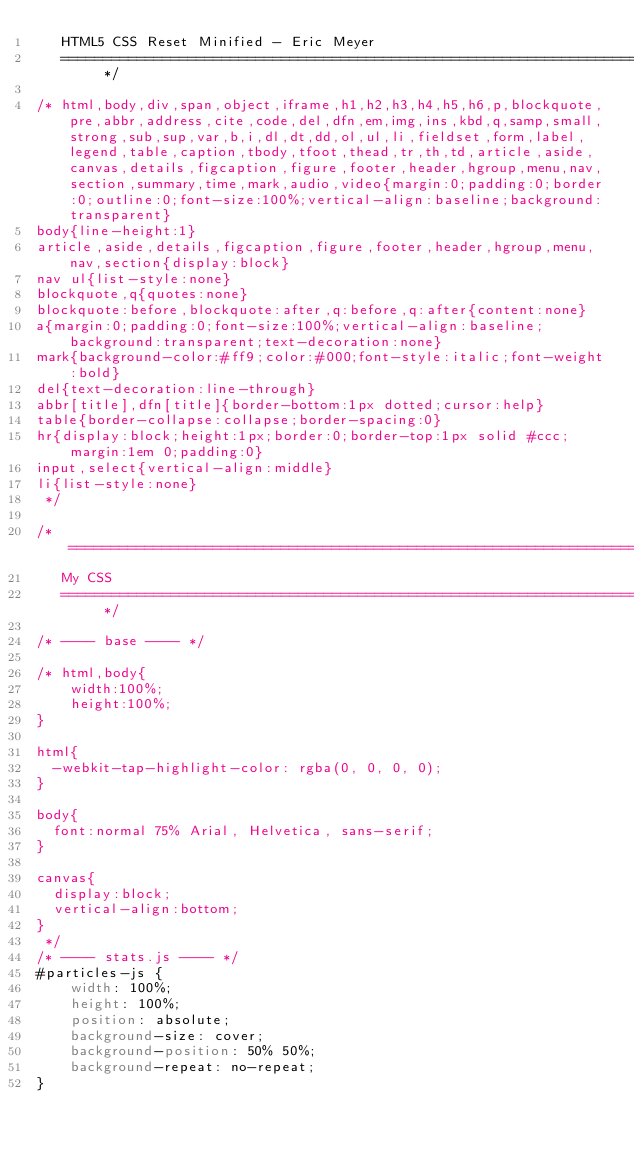<code> <loc_0><loc_0><loc_500><loc_500><_CSS_>   HTML5 CSS Reset Minified - Eric Meyer
   ========================================================================== */

/* html,body,div,span,object,iframe,h1,h2,h3,h4,h5,h6,p,blockquote,pre,abbr,address,cite,code,del,dfn,em,img,ins,kbd,q,samp,small,strong,sub,sup,var,b,i,dl,dt,dd,ol,ul,li,fieldset,form,label,legend,table,caption,tbody,tfoot,thead,tr,th,td,article,aside,canvas,details,figcaption,figure,footer,header,hgroup,menu,nav,section,summary,time,mark,audio,video{margin:0;padding:0;border:0;outline:0;font-size:100%;vertical-align:baseline;background:transparent}
body{line-height:1}
article,aside,details,figcaption,figure,footer,header,hgroup,menu,nav,section{display:block}
nav ul{list-style:none}
blockquote,q{quotes:none}
blockquote:before,blockquote:after,q:before,q:after{content:none}
a{margin:0;padding:0;font-size:100%;vertical-align:baseline;background:transparent;text-decoration:none}
mark{background-color:#ff9;color:#000;font-style:italic;font-weight:bold}
del{text-decoration:line-through}
abbr[title],dfn[title]{border-bottom:1px dotted;cursor:help}
table{border-collapse:collapse;border-spacing:0}
hr{display:block;height:1px;border:0;border-top:1px solid #ccc;margin:1em 0;padding:0}
input,select{vertical-align:middle}
li{list-style:none}
 */

/* =============================================================================
   My CSS
   ========================================================================== */

/* ---- base ---- */

/* html,body{
	width:100%;
	height:100%;
}

html{
  -webkit-tap-highlight-color: rgba(0, 0, 0, 0);
}

body{
  font:normal 75% Arial, Helvetica, sans-serif;
}

canvas{
  display:block;
  vertical-align:bottom;
}
 */
/* ---- stats.js ---- */
#particles-js {
    width: 100%;
    height: 100%;
    position: absolute;
    background-size: cover;
    background-position: 50% 50%;
    background-repeat: no-repeat;
}
</code> 